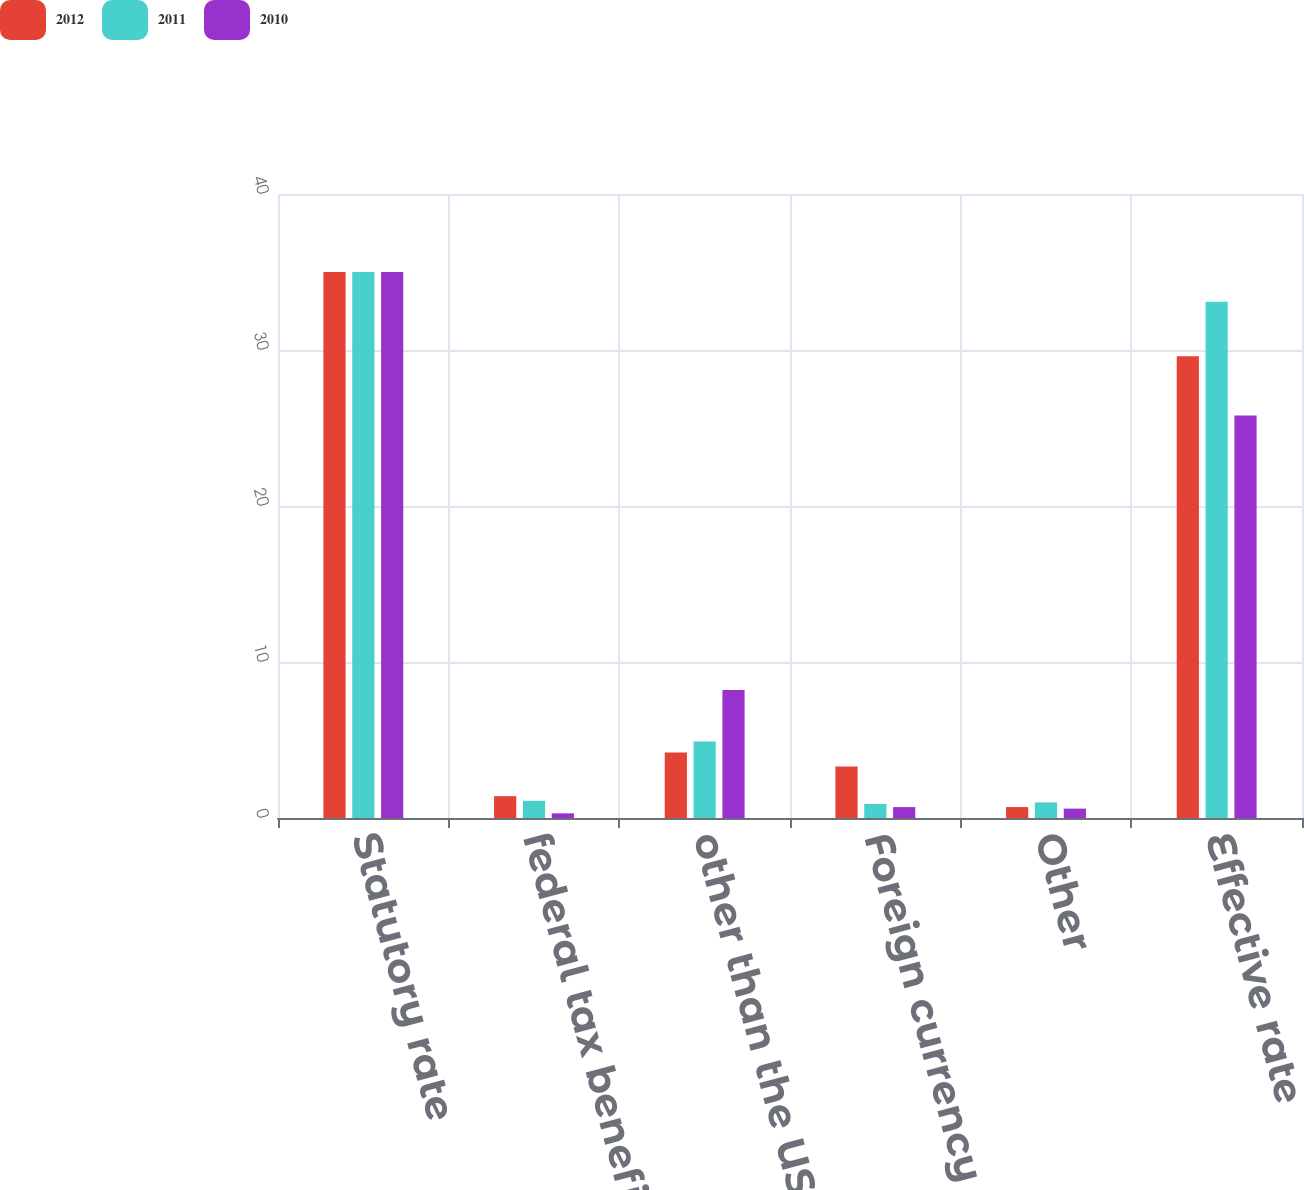Convert chart to OTSL. <chart><loc_0><loc_0><loc_500><loc_500><stacked_bar_chart><ecel><fcel>Statutory rate<fcel>federal tax benefit<fcel>other than the US statutory<fcel>Foreign currency remeasurement<fcel>Other<fcel>Effective rate<nl><fcel>2012<fcel>35<fcel>1.4<fcel>4.2<fcel>3.3<fcel>0.7<fcel>29.6<nl><fcel>2011<fcel>35<fcel>1.1<fcel>4.9<fcel>0.9<fcel>1<fcel>33.1<nl><fcel>2010<fcel>35<fcel>0.3<fcel>8.2<fcel>0.7<fcel>0.6<fcel>25.8<nl></chart> 